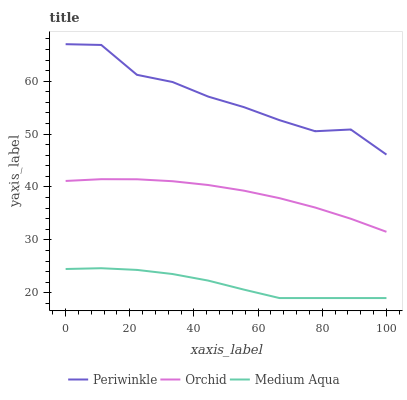Does Medium Aqua have the minimum area under the curve?
Answer yes or no. Yes. Does Periwinkle have the maximum area under the curve?
Answer yes or no. Yes. Does Orchid have the minimum area under the curve?
Answer yes or no. No. Does Orchid have the maximum area under the curve?
Answer yes or no. No. Is Orchid the smoothest?
Answer yes or no. Yes. Is Periwinkle the roughest?
Answer yes or no. Yes. Is Periwinkle the smoothest?
Answer yes or no. No. Is Orchid the roughest?
Answer yes or no. No. Does Orchid have the lowest value?
Answer yes or no. No. Does Orchid have the highest value?
Answer yes or no. No. Is Medium Aqua less than Orchid?
Answer yes or no. Yes. Is Orchid greater than Medium Aqua?
Answer yes or no. Yes. Does Medium Aqua intersect Orchid?
Answer yes or no. No. 